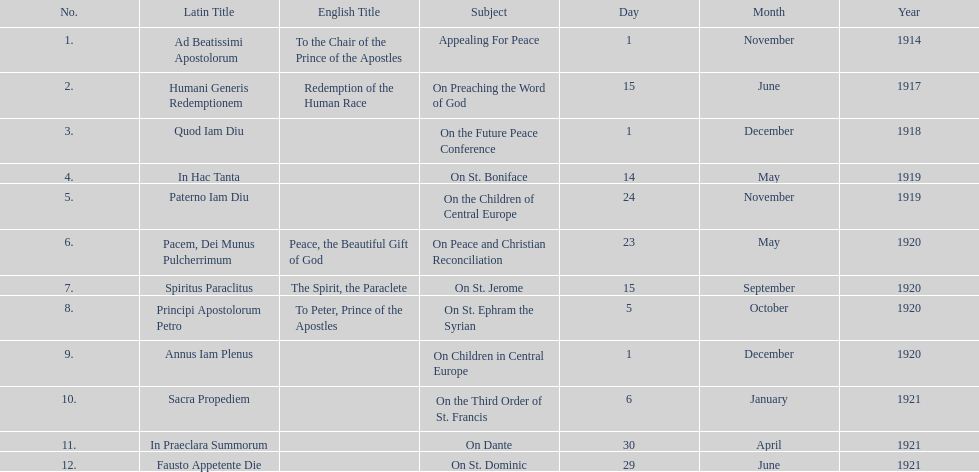How many titles did not list an english translation? 7. 